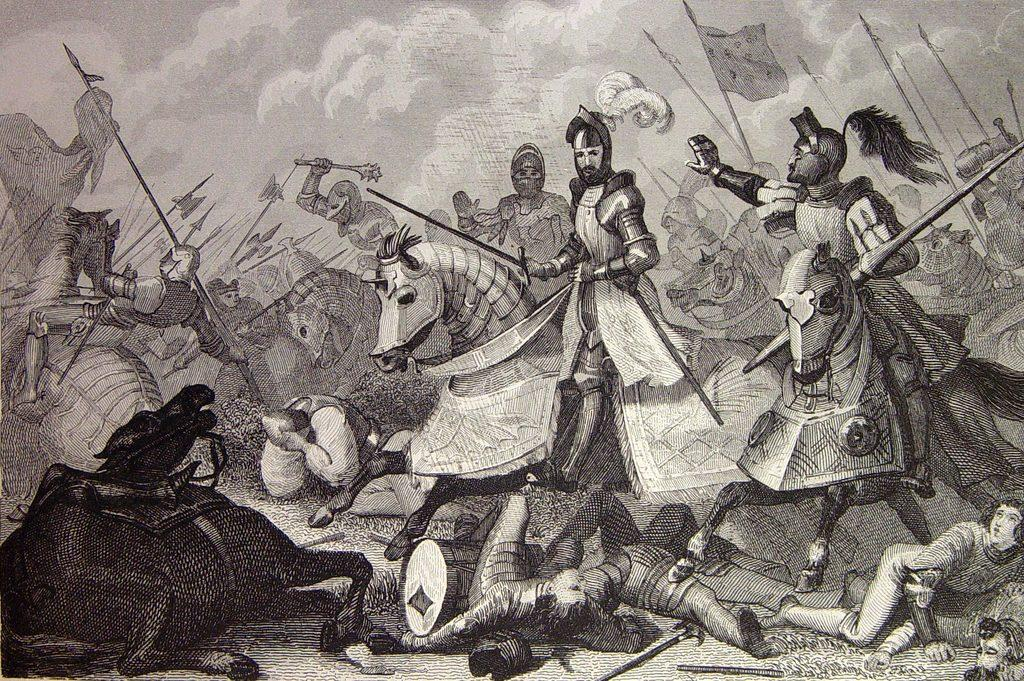What is the main subject of the sketch in the image? The main subject of the sketch in the image is horses. What are the people in the sketch doing with the horses? The people in the sketch are depicted sitting on the horses. What are the people holding in their hands in the sketch? The people in the sketch are holding objects in their hands. What is the background of the sketch in the image? There is a sketch of the sky in the image. How many bears can be seen playing in the alley in the image? There are no bears or alleys present in the image; it features a sketch of horses with people sitting on them. 